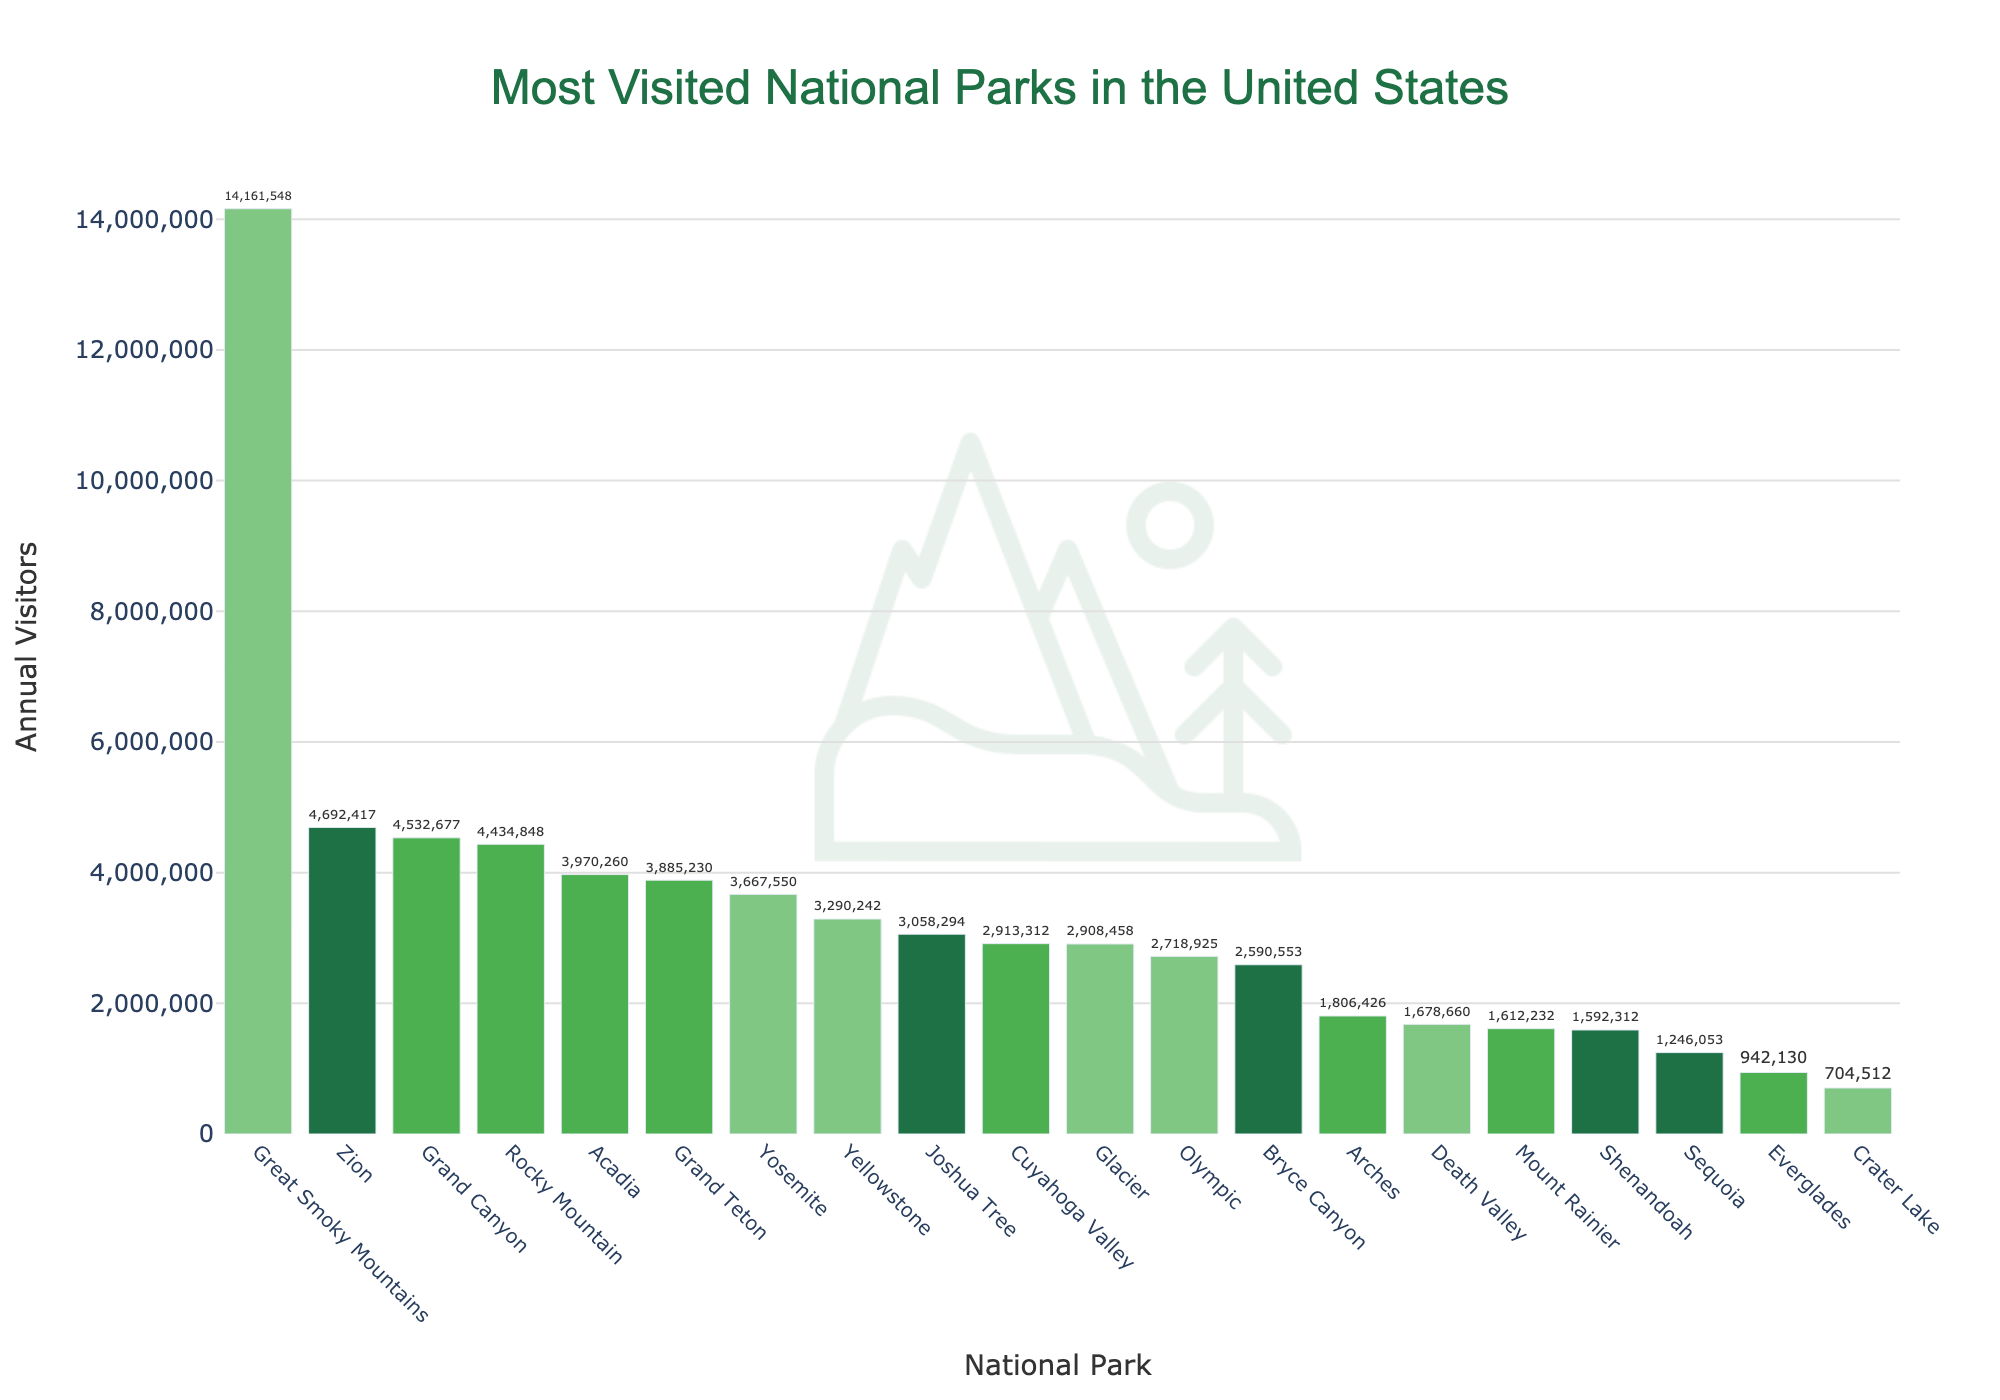What national park receives the highest number of visitors annually? By closely reviewing the bars, "Great Smoky Mountains" has the tallest bar indicating this park has the highest number of annual visitors.
Answer: Great Smoky Mountains What is the difference in annual visitors between Grand Canyon and Zion National Park? From the chart, "Grand Canyon" has 4,532,677 visitors, and "Zion" has 4,692,417 visitors. The difference is 4,692,417 - 4,532,677.
Answer: 159,740 What's the sum of visitors to Yosemite and Yellowstone? The bar chart shows Yosemite has 3,667,550 visitors, and Yellowstone has 3,290,242 visitors. Adding them together gives 3,667,550 + 3,290,242.
Answer: 6,957,792 Which park, Shenandoah or Cuyahoga Valley, has fewer visitors? The chart shows Shenandoah with 1,592,312 visitors and Cuyahoga Valley with 2,913,312 visitors. Shenandoah has fewer visitors.
Answer: Shenandoah What’s the average number of visitors among Rocky Mountain, Yosemite, and Acadia? Rocky Mountain has 4,434,848 visitors, Yosemite has 3,667,550 visitors, and Acadia has 3,970,260 visitors. The sum is 4,434,848 + 3,667,550 + 3,970,260 = 12,072,658. Dividing by 3 gives the average.
Answer: 4,024,219 How many parks have more than 3 million visitors annually? By counting the bars exceeding 3 million visitors, the national parks are Great Smoky Mountains, Grand Canyon, Zion, Rocky Mountain, Yosemite, Acadia, Grand Teton, and Joshua Tree. There are 8 parks.
Answer: 8 Which two parks have the most similar number of visitors? By visually examining the height of the bars, Glacier with 2,908,458 visitors and Cuyahoga Valley with 2,913,312 visitors are very close in number.
Answer: Glacier and Cuyahoga Valley Which has a higher visitor count, Olympic or Joshua Tree? The chart indicates Olympic has 2,718,925 visitors, and Joshua Tree has 3,058,294 visitors. Thus, Joshua Tree has a higher count.
Answer: Joshua Tree What is the range of the visitor counts? The highest visitor count is 14,161,548 (Great Smoky Mountains) and the lowest is 704,512 (Crater Lake). The range is 14,161,548 - 704,512.
Answer: 13,457,036 What is the total number of visitors for the three least visited parks? The least visited parks are Crater Lake (704,512), Everglades (942,130), and Sequoia (1,246,053). Adding these gives 704,512 + 942,130 + 1,246,053.
Answer: 2,892,695 